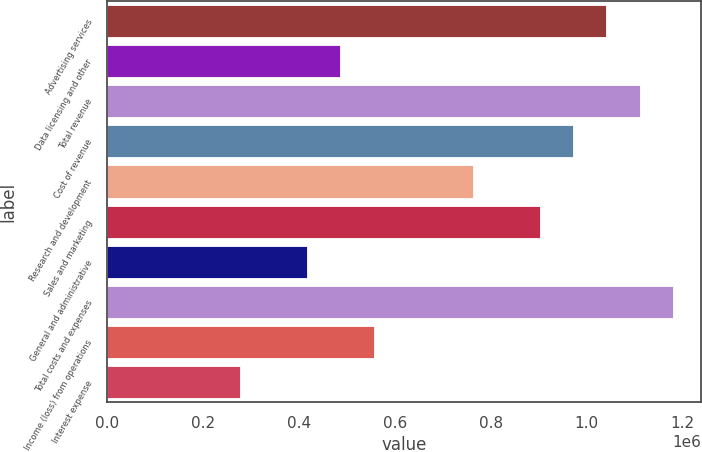Convert chart. <chart><loc_0><loc_0><loc_500><loc_500><bar_chart><fcel>Advertising services<fcel>Data licensing and other<fcel>Total revenue<fcel>Cost of revenue<fcel>Research and development<fcel>Sales and marketing<fcel>General and administrative<fcel>Total costs and expenses<fcel>Income (loss) from operations<fcel>Interest expense<nl><fcel>1.04103e+06<fcel>485816<fcel>1.11044e+06<fcel>971632<fcel>763425<fcel>902230<fcel>416414<fcel>1.17984e+06<fcel>555218<fcel>277609<nl></chart> 